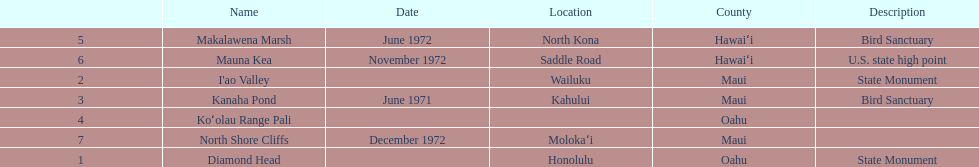Would you be able to parse every entry in this table? {'header': ['', 'Name', 'Date', 'Location', 'County', 'Description'], 'rows': [['5', 'Makalawena Marsh', 'June 1972', 'North Kona', 'Hawaiʻi', 'Bird Sanctuary'], ['6', 'Mauna Kea', 'November 1972', 'Saddle Road', 'Hawaiʻi', 'U.S. state high point'], ['2', "I'ao Valley", '', 'Wailuku', 'Maui', 'State Monument'], ['3', 'Kanaha Pond', 'June 1971', 'Kahului', 'Maui', 'Bird Sanctuary'], ['4', 'Koʻolau Range Pali', '', '', 'Oahu', ''], ['7', 'North Shore Cliffs', 'December 1972', 'Molokaʻi', 'Maui', ''], ['1', 'Diamond Head', '', 'Honolulu', 'Oahu', 'State Monument']]} What are the total number of landmarks located in maui? 3. 